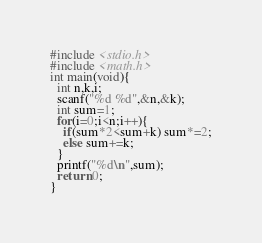Convert code to text. <code><loc_0><loc_0><loc_500><loc_500><_C_>#include <stdio.h>
#include <math.h>
int main(void){
  int n,k,i;
  scanf("%d %d",&n,&k);
  int sum=1;
  for(i=0;i<n;i++){
    if(sum*2<sum+k) sum*=2;
    else sum+=k;
  }
  printf("%d\n",sum);
  return 0;
}</code> 